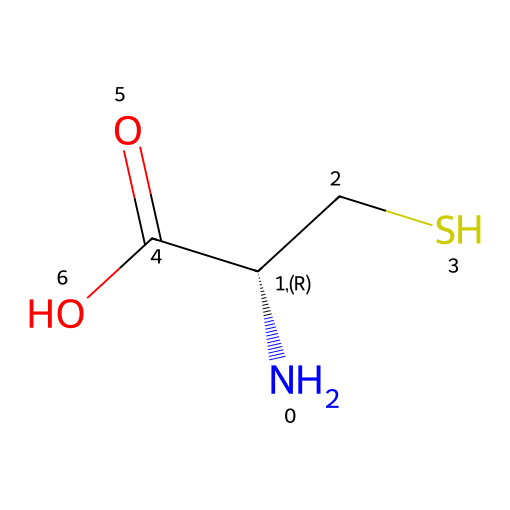What is the name of the sulfur-containing amino acid in this structure? The structure contains a sulfur atom bonded to a carbon (CS), which indicates it is a cysteine amino acid. The SMILES notation reflects this.
Answer: cysteine How many carbon atoms are present in this compound? The structure includes the carbon atoms in the backbone (three in total: one in the amino group and two in the cysteine side chain) as identified by 'C' in the SMILES.
Answer: 3 What type of bond connects the amino group to the carbon chain? The bond between the amino group (N) and the carbon chain (the central 'C') is a single covalent bond, shown by the adjacency of 'N' to 'C' in the SMILES representation.
Answer: single How does the presence of the sulfur atom affect protein structure? Sulfur atoms in amino acids like cysteine can form disulfide bonds, which are crucial for stabilizing the tertiary and quaternary structures of proteins, contributing to their overall 3D shape.
Answer: disulfide bonds Describe the functional group present in this structure. The structure contains a carboxylic acid functional group ('C(=O)O'), which indicates it can donate protons, making this a carboxylic acid functional group central to amino acids.
Answer: carboxylic acid What is the stereochemistry of the central carbon atom? The central carbon atom is indicated as being chiral by 'C@@H,' meaning it has a specific configuration that is essential for its function in protein folding and interactions.
Answer: chiral Is the compound polar or nonpolar and why? This compound is polar due to the presence of the carboxylic acid group and the amino group, both of which can engage in hydrogen bonding, resulting in a polar character.
Answer: polar 